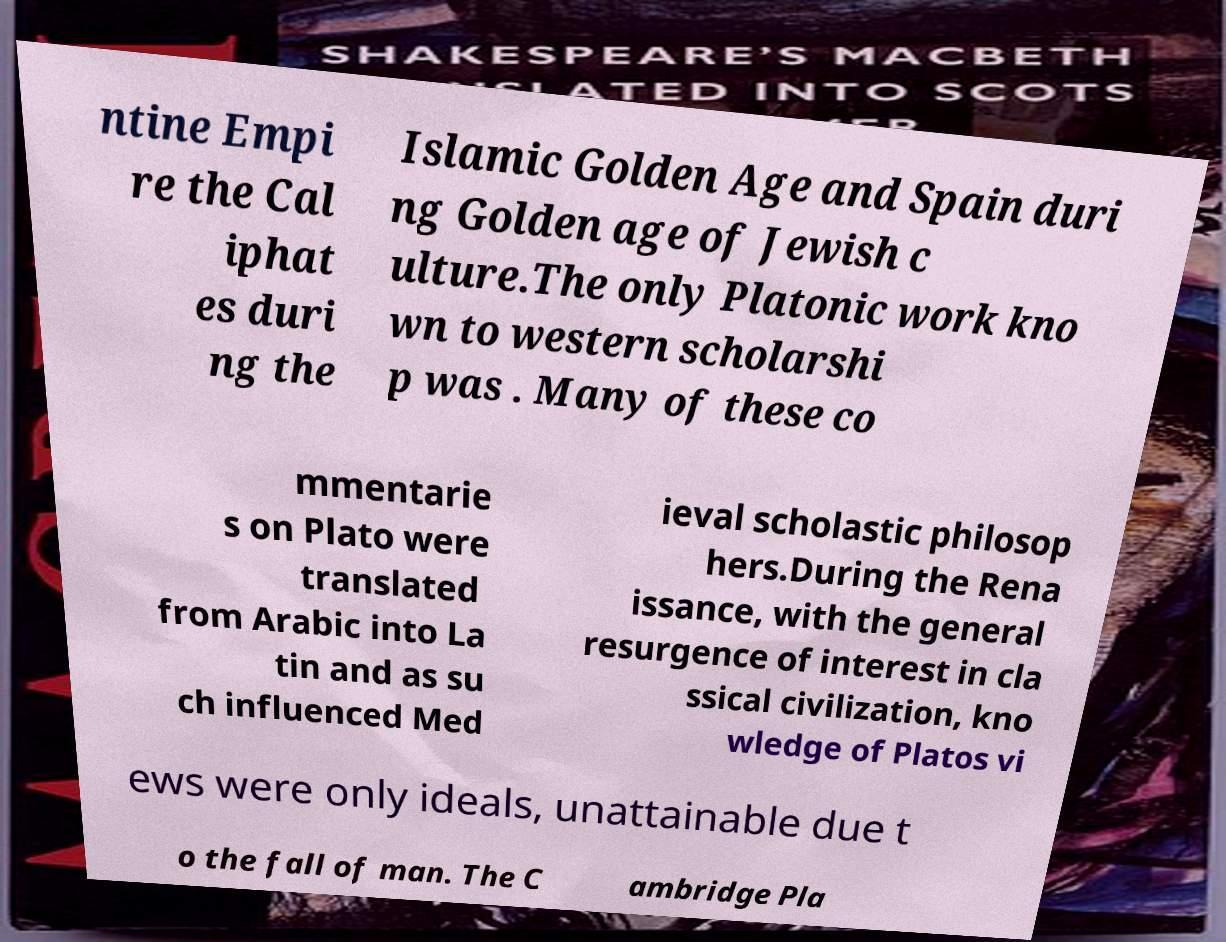For documentation purposes, I need the text within this image transcribed. Could you provide that? ntine Empi re the Cal iphat es duri ng the Islamic Golden Age and Spain duri ng Golden age of Jewish c ulture.The only Platonic work kno wn to western scholarshi p was . Many of these co mmentarie s on Plato were translated from Arabic into La tin and as su ch influenced Med ieval scholastic philosop hers.During the Rena issance, with the general resurgence of interest in cla ssical civilization, kno wledge of Platos vi ews were only ideals, unattainable due t o the fall of man. The C ambridge Pla 